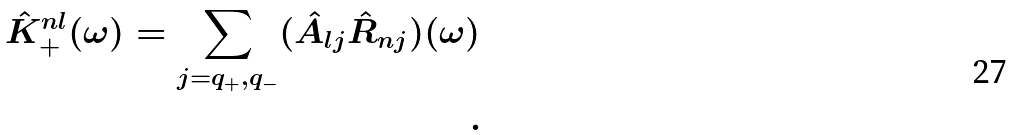Convert formula to latex. <formula><loc_0><loc_0><loc_500><loc_500>\hat { K } _ { + } ^ { n l } ( \omega ) = \sum _ { j = q _ { + } , q _ { - } } ( \hat { A } _ { l j } \hat { R } _ { n j } ) ( \omega ) \\ .</formula> 